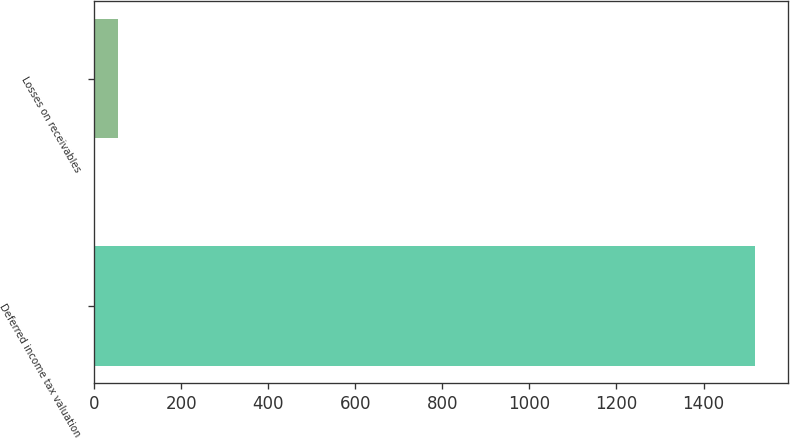<chart> <loc_0><loc_0><loc_500><loc_500><bar_chart><fcel>Deferred income tax valuation<fcel>Losses on receivables<nl><fcel>1519<fcel>55<nl></chart> 